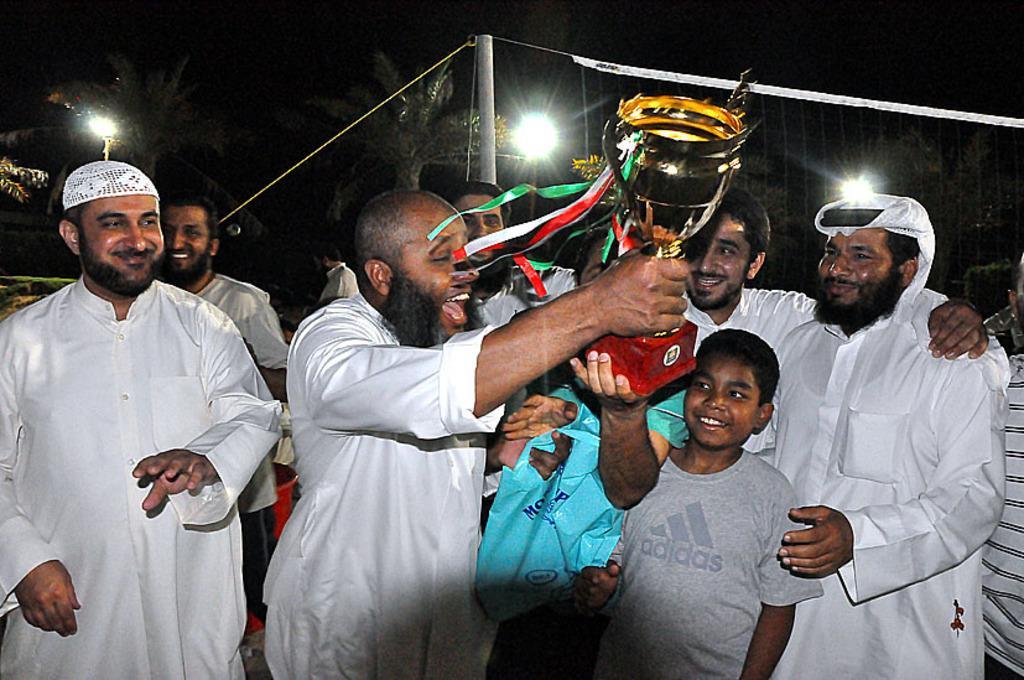Describe this image in one or two sentences. In this picture there is a man standing and holding the object and there are group of people standing and smiling. At the back there are trees and there is a net on the pole. At the top there is sky. 